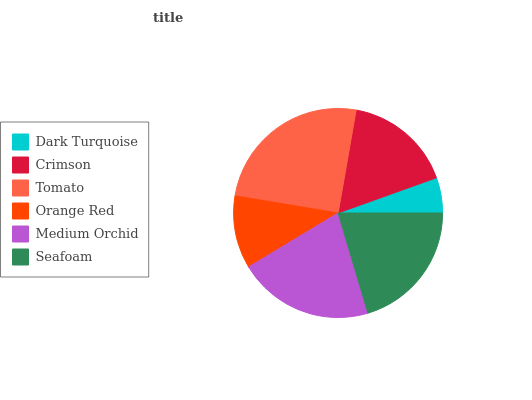Is Dark Turquoise the minimum?
Answer yes or no. Yes. Is Tomato the maximum?
Answer yes or no. Yes. Is Crimson the minimum?
Answer yes or no. No. Is Crimson the maximum?
Answer yes or no. No. Is Crimson greater than Dark Turquoise?
Answer yes or no. Yes. Is Dark Turquoise less than Crimson?
Answer yes or no. Yes. Is Dark Turquoise greater than Crimson?
Answer yes or no. No. Is Crimson less than Dark Turquoise?
Answer yes or no. No. Is Seafoam the high median?
Answer yes or no. Yes. Is Crimson the low median?
Answer yes or no. Yes. Is Medium Orchid the high median?
Answer yes or no. No. Is Medium Orchid the low median?
Answer yes or no. No. 